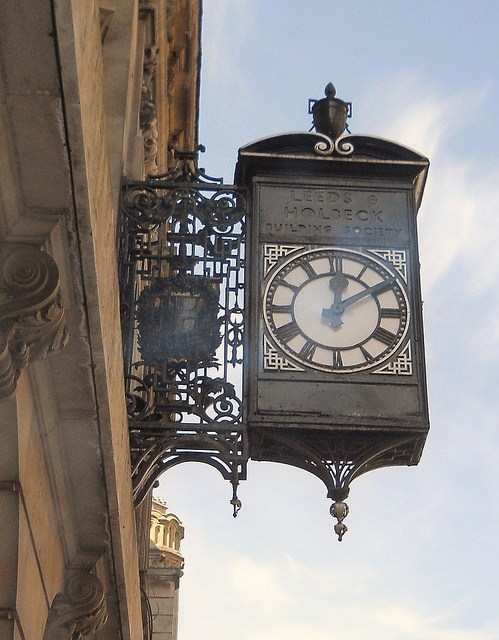Describe the objects in this image and their specific colors. I can see a clock in gray, darkgray, and lightgray tones in this image. 